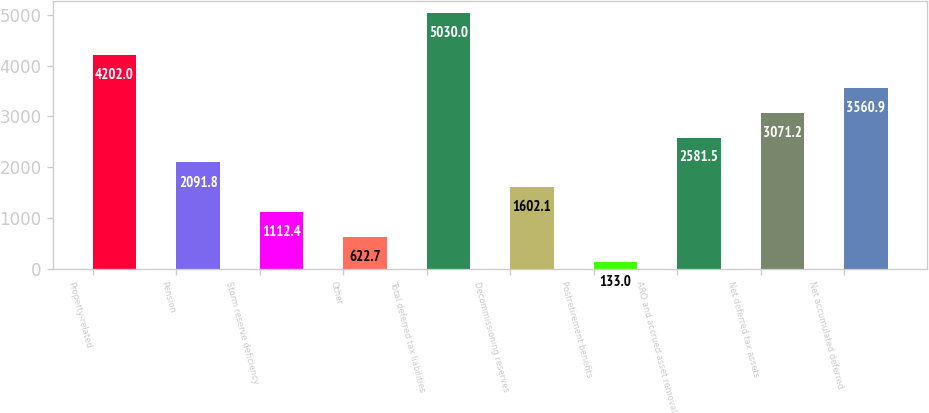Convert chart. <chart><loc_0><loc_0><loc_500><loc_500><bar_chart><fcel>Property-related<fcel>Pension<fcel>Storm reserve deficiency<fcel>Other<fcel>Total deferred tax liabilities<fcel>Decommissioning reserves<fcel>Postretirement benefits<fcel>ARO and accrued asset removal<fcel>Net deferred tax assets<fcel>Net accumulated deferred<nl><fcel>4202<fcel>2091.8<fcel>1112.4<fcel>622.7<fcel>5030<fcel>1602.1<fcel>133<fcel>2581.5<fcel>3071.2<fcel>3560.9<nl></chart> 